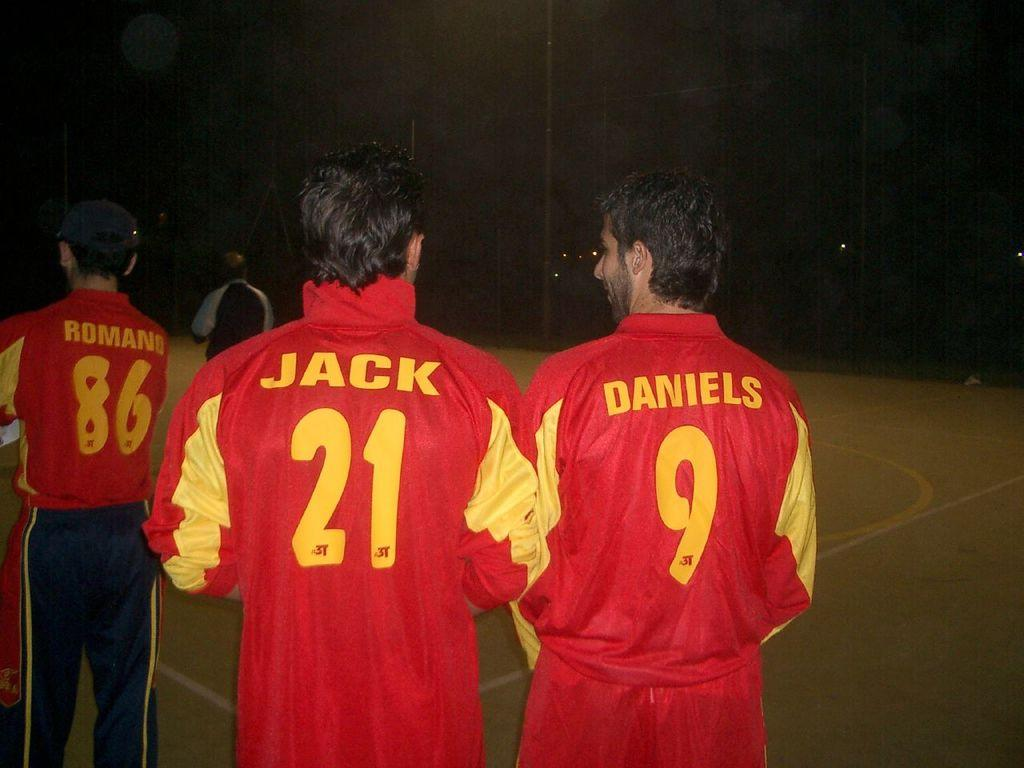How many people are in the image? There are people in the image. Can you describe the clothing of one of the people? One person is wearing a cap on the left side. What can be observed about the background of the image? The background of the image appears dark. What type of territory is being claimed by the person wearing the cap in the image? There is no indication in the image that anyone is claiming territory, and the person wearing the cap is not shown doing so. 